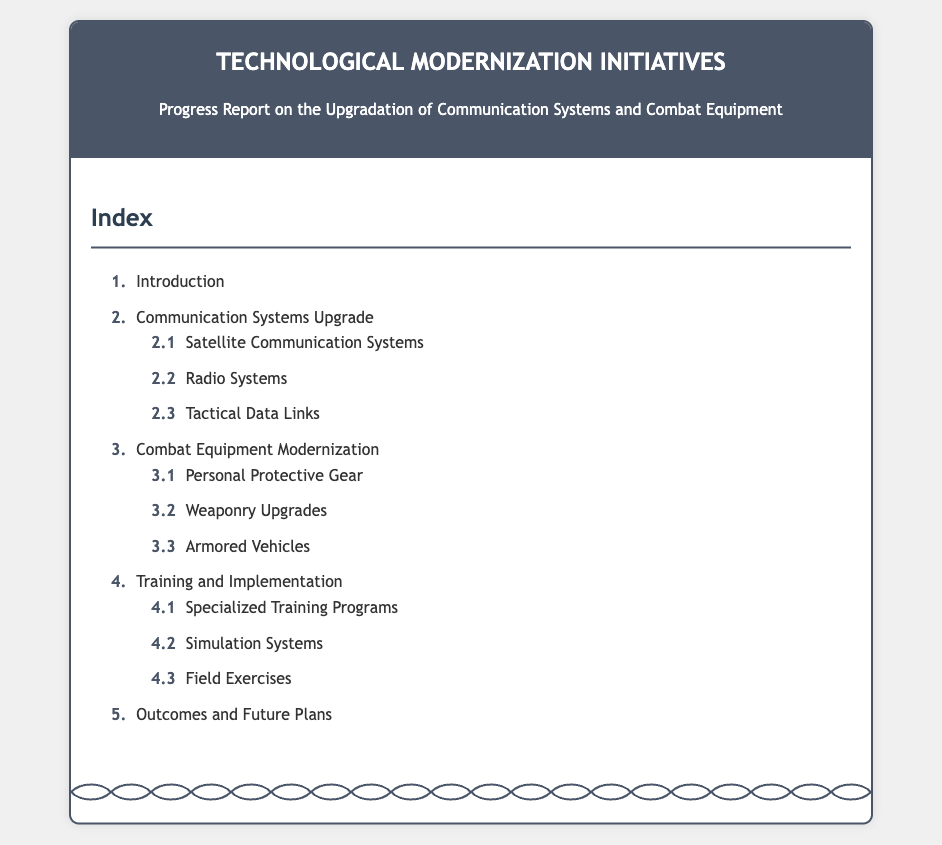What is the title of the document? The title is stated at the top of the document, which summarizes its focus.
Answer: Technological Modernization Initiatives How many main sections are in the index? The number of main sections is found by counting the primary items listed in the index.
Answer: 5 What is section 2 about? This section is explicitly titled in the document and defines the area of focus.
Answer: Communication Systems Upgrade What subsection falls under the Communication Systems Upgrade? This is mentioned in the list under section 2, requiring identification of specific subsections.
Answer: Satellite Communication Systems, Radio Systems, Tactical Data Links What is the first subsection under Combat Equipment Modernization? The subsections are numbered, allowing for easy identification of the first item.
Answer: Personal Protective Gear What is the last section in the index? The last section is clearly labeled at the end of the list.
Answer: Outcomes and Future Plans What is the focus of section 4 in the document? This section includes specific practices aimed at enhancing skills, as titled in the document.
Answer: Training and Implementation Which section includes Field Exercises? The specific context of Field Exercises can be found by looking at its associated section in the document.
Answer: Training and Implementation 